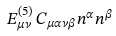<formula> <loc_0><loc_0><loc_500><loc_500>E _ { \mu \nu } ^ { ( 5 ) \, } C _ { \mu \alpha \nu \beta } n ^ { \alpha } n ^ { \beta }</formula> 